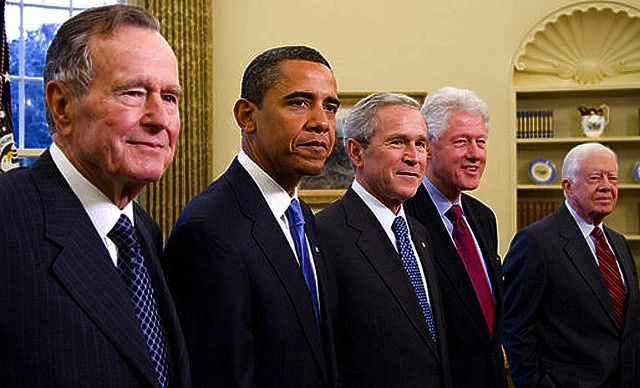Describe the objects in this image and their specific colors. I can see people in black, maroon, lightpink, and brown tones, people in black, maroon, brown, and white tones, people in black, brown, maroon, and salmon tones, people in black, maroon, brown, and lightgray tones, and people in black, maroon, brown, and lightpink tones in this image. 